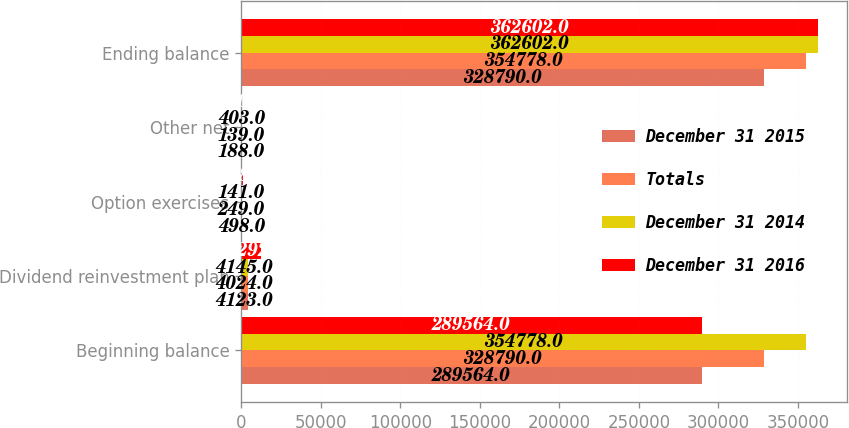<chart> <loc_0><loc_0><loc_500><loc_500><stacked_bar_chart><ecel><fcel>Beginning balance<fcel>Dividend reinvestment plan<fcel>Option exercises<fcel>Other net<fcel>Ending balance<nl><fcel>December 31 2015<fcel>289564<fcel>4123<fcel>498<fcel>188<fcel>328790<nl><fcel>Totals<fcel>328790<fcel>4024<fcel>249<fcel>139<fcel>354778<nl><fcel>December 31 2014<fcel>354778<fcel>4145<fcel>141<fcel>403<fcel>362602<nl><fcel>December 31 2016<fcel>289564<fcel>12292<fcel>888<fcel>730<fcel>362602<nl></chart> 